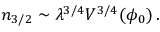<formula> <loc_0><loc_0><loc_500><loc_500>n _ { 3 / 2 } \sim \lambda ^ { 3 / 4 } V ^ { 3 / 4 } ( \phi _ { 0 } ) \, .</formula> 